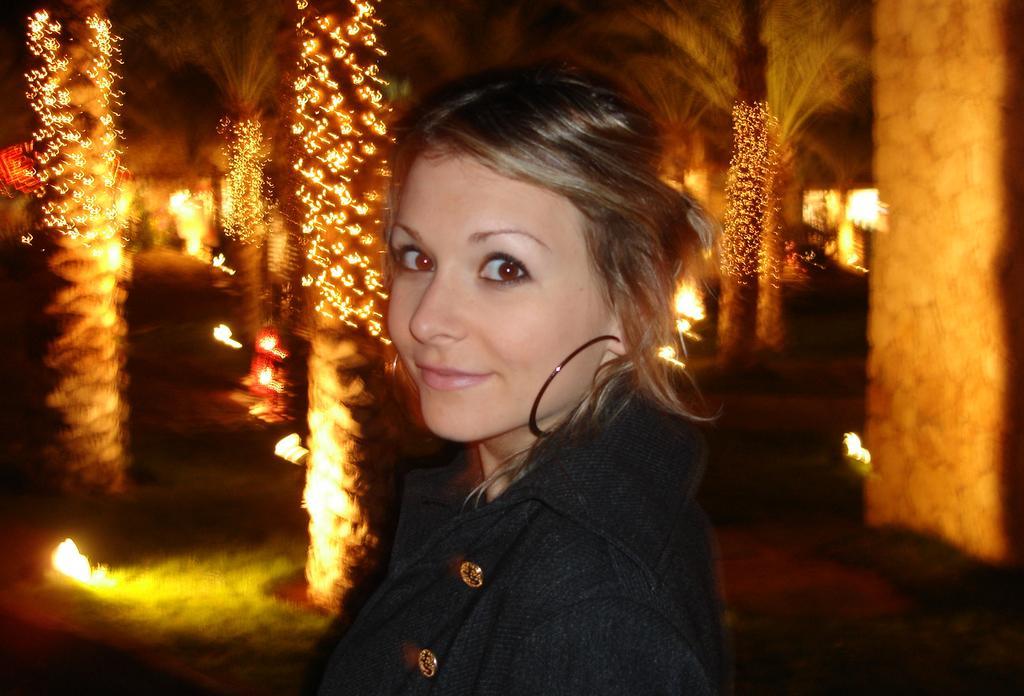Can you describe this image briefly? In this picture we can see a woman, she is smiling and in the background we can see lights, trees and some objects. 